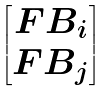Convert formula to latex. <formula><loc_0><loc_0><loc_500><loc_500>\begin{bmatrix} F B _ { i } \\ F B _ { j } \end{bmatrix}</formula> 